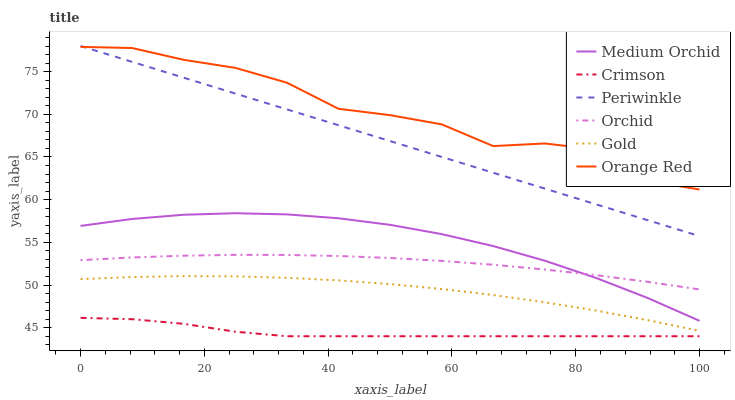Does Crimson have the minimum area under the curve?
Answer yes or no. Yes. Does Orange Red have the maximum area under the curve?
Answer yes or no. Yes. Does Medium Orchid have the minimum area under the curve?
Answer yes or no. No. Does Medium Orchid have the maximum area under the curve?
Answer yes or no. No. Is Periwinkle the smoothest?
Answer yes or no. Yes. Is Orange Red the roughest?
Answer yes or no. Yes. Is Medium Orchid the smoothest?
Answer yes or no. No. Is Medium Orchid the roughest?
Answer yes or no. No. Does Crimson have the lowest value?
Answer yes or no. Yes. Does Medium Orchid have the lowest value?
Answer yes or no. No. Does Periwinkle have the highest value?
Answer yes or no. Yes. Does Medium Orchid have the highest value?
Answer yes or no. No. Is Gold less than Orange Red?
Answer yes or no. Yes. Is Orange Red greater than Gold?
Answer yes or no. Yes. Does Orchid intersect Medium Orchid?
Answer yes or no. Yes. Is Orchid less than Medium Orchid?
Answer yes or no. No. Is Orchid greater than Medium Orchid?
Answer yes or no. No. Does Gold intersect Orange Red?
Answer yes or no. No. 